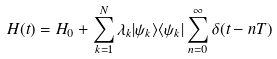<formula> <loc_0><loc_0><loc_500><loc_500>H ( t ) = H _ { 0 } + \sum _ { k = 1 } ^ { N } \lambda _ { k } | \psi _ { k } \rangle \langle \psi _ { k } | \sum _ { n = 0 } ^ { \infty } \delta ( t - n T )</formula> 